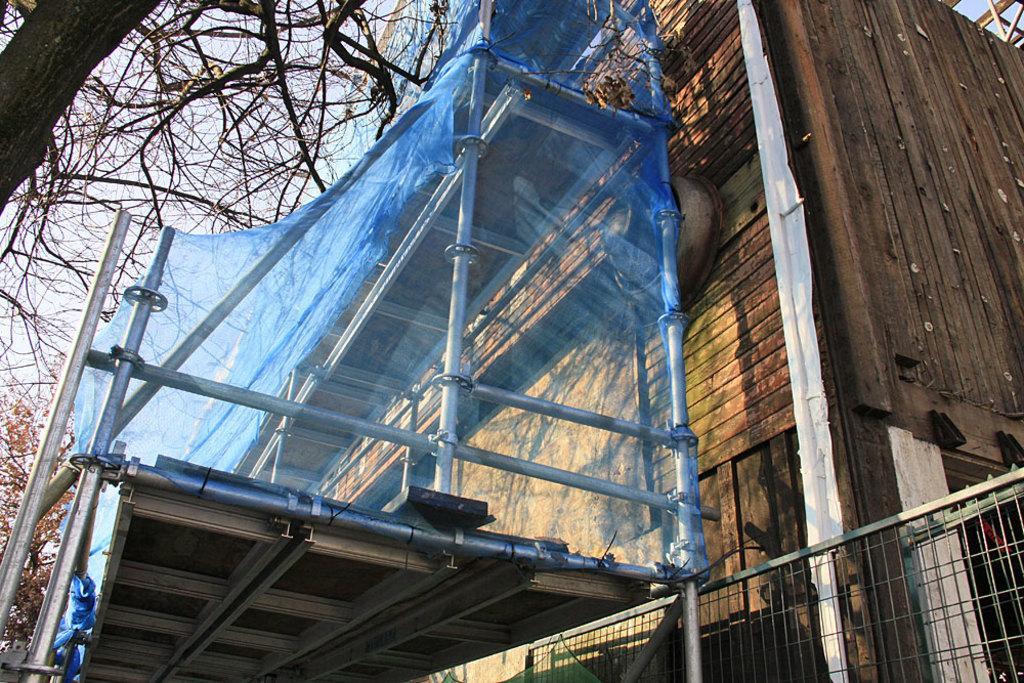Please provide a concise description of this image. In this image I can see a building, fence, trees and other objects. In the background I can see the sky. 